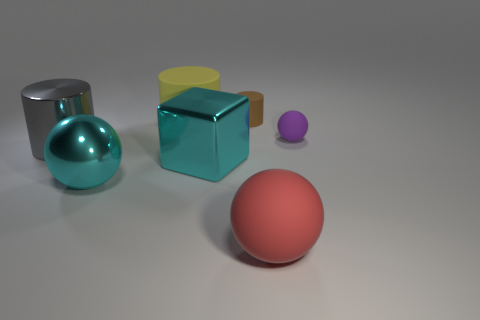Add 4 metallic blocks. How many metallic blocks are left? 5 Add 7 purple metallic things. How many purple metallic things exist? 7 Add 1 tiny matte things. How many objects exist? 8 Subtract all yellow cylinders. How many cylinders are left? 2 Subtract all big spheres. How many spheres are left? 1 Subtract 1 cyan spheres. How many objects are left? 6 Subtract all cylinders. How many objects are left? 4 Subtract all brown cylinders. Subtract all brown blocks. How many cylinders are left? 2 Subtract all blue cylinders. How many brown balls are left? 0 Subtract all yellow cylinders. Subtract all small brown matte cylinders. How many objects are left? 5 